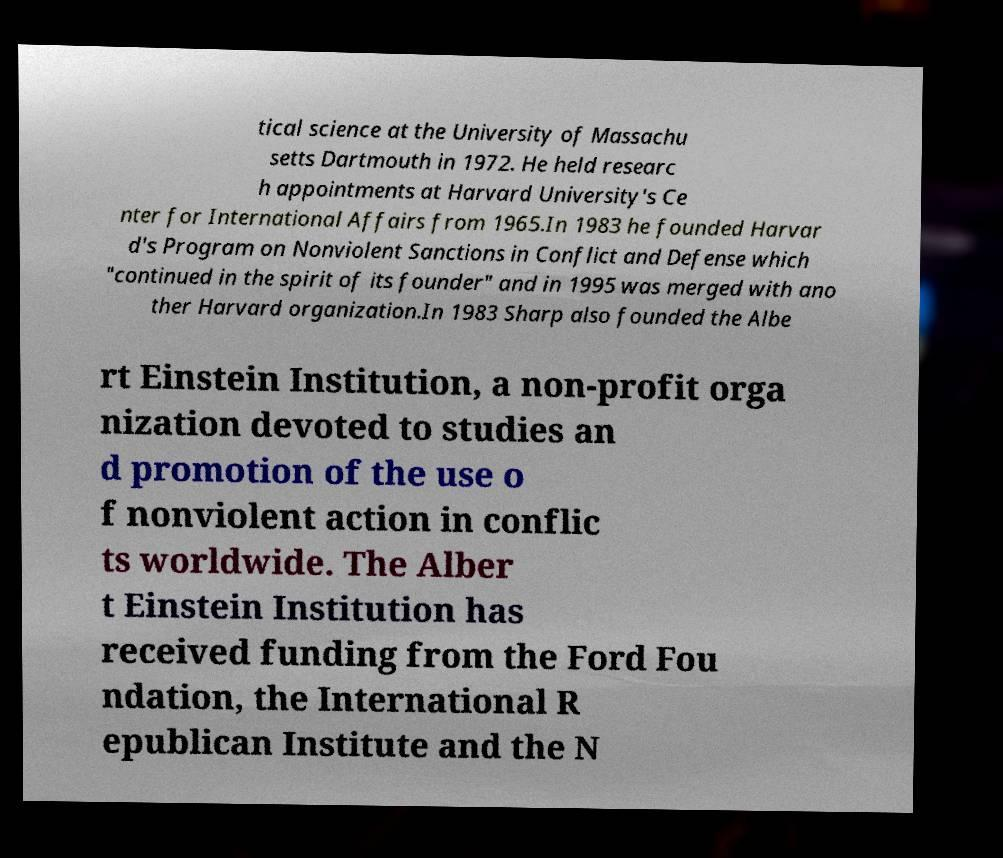Please identify and transcribe the text found in this image. tical science at the University of Massachu setts Dartmouth in 1972. He held researc h appointments at Harvard University's Ce nter for International Affairs from 1965.In 1983 he founded Harvar d's Program on Nonviolent Sanctions in Conflict and Defense which "continued in the spirit of its founder" and in 1995 was merged with ano ther Harvard organization.In 1983 Sharp also founded the Albe rt Einstein Institution, a non-profit orga nization devoted to studies an d promotion of the use o f nonviolent action in conflic ts worldwide. The Alber t Einstein Institution has received funding from the Ford Fou ndation, the International R epublican Institute and the N 